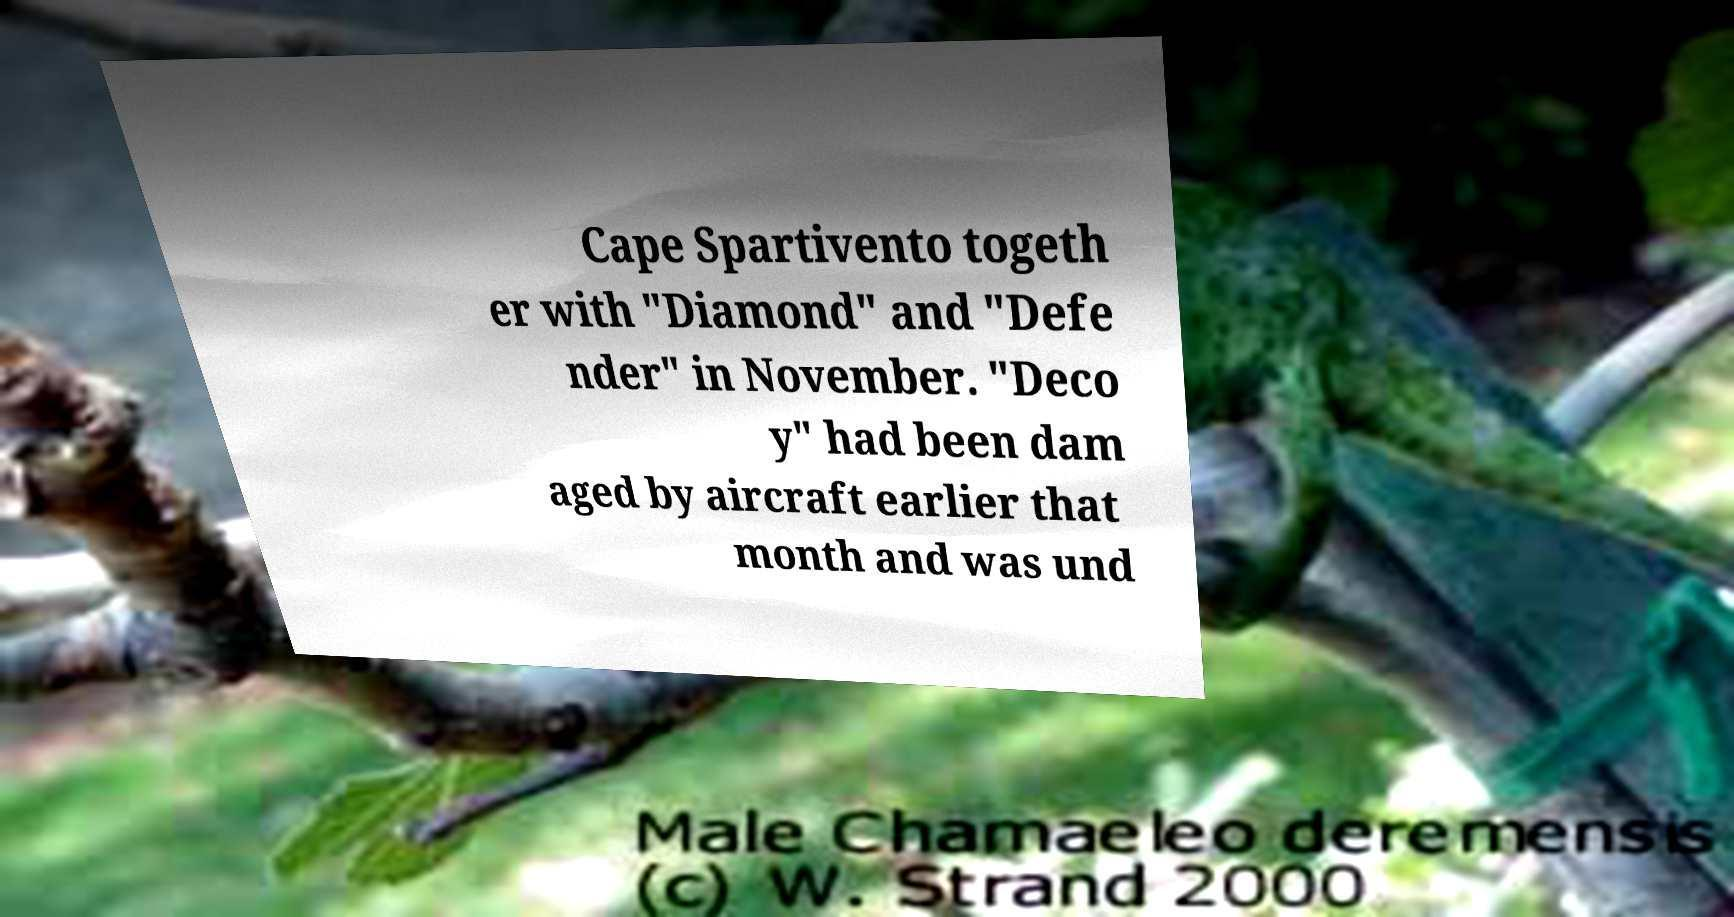Please identify and transcribe the text found in this image. Cape Spartivento togeth er with "Diamond" and "Defe nder" in November. "Deco y" had been dam aged by aircraft earlier that month and was und 